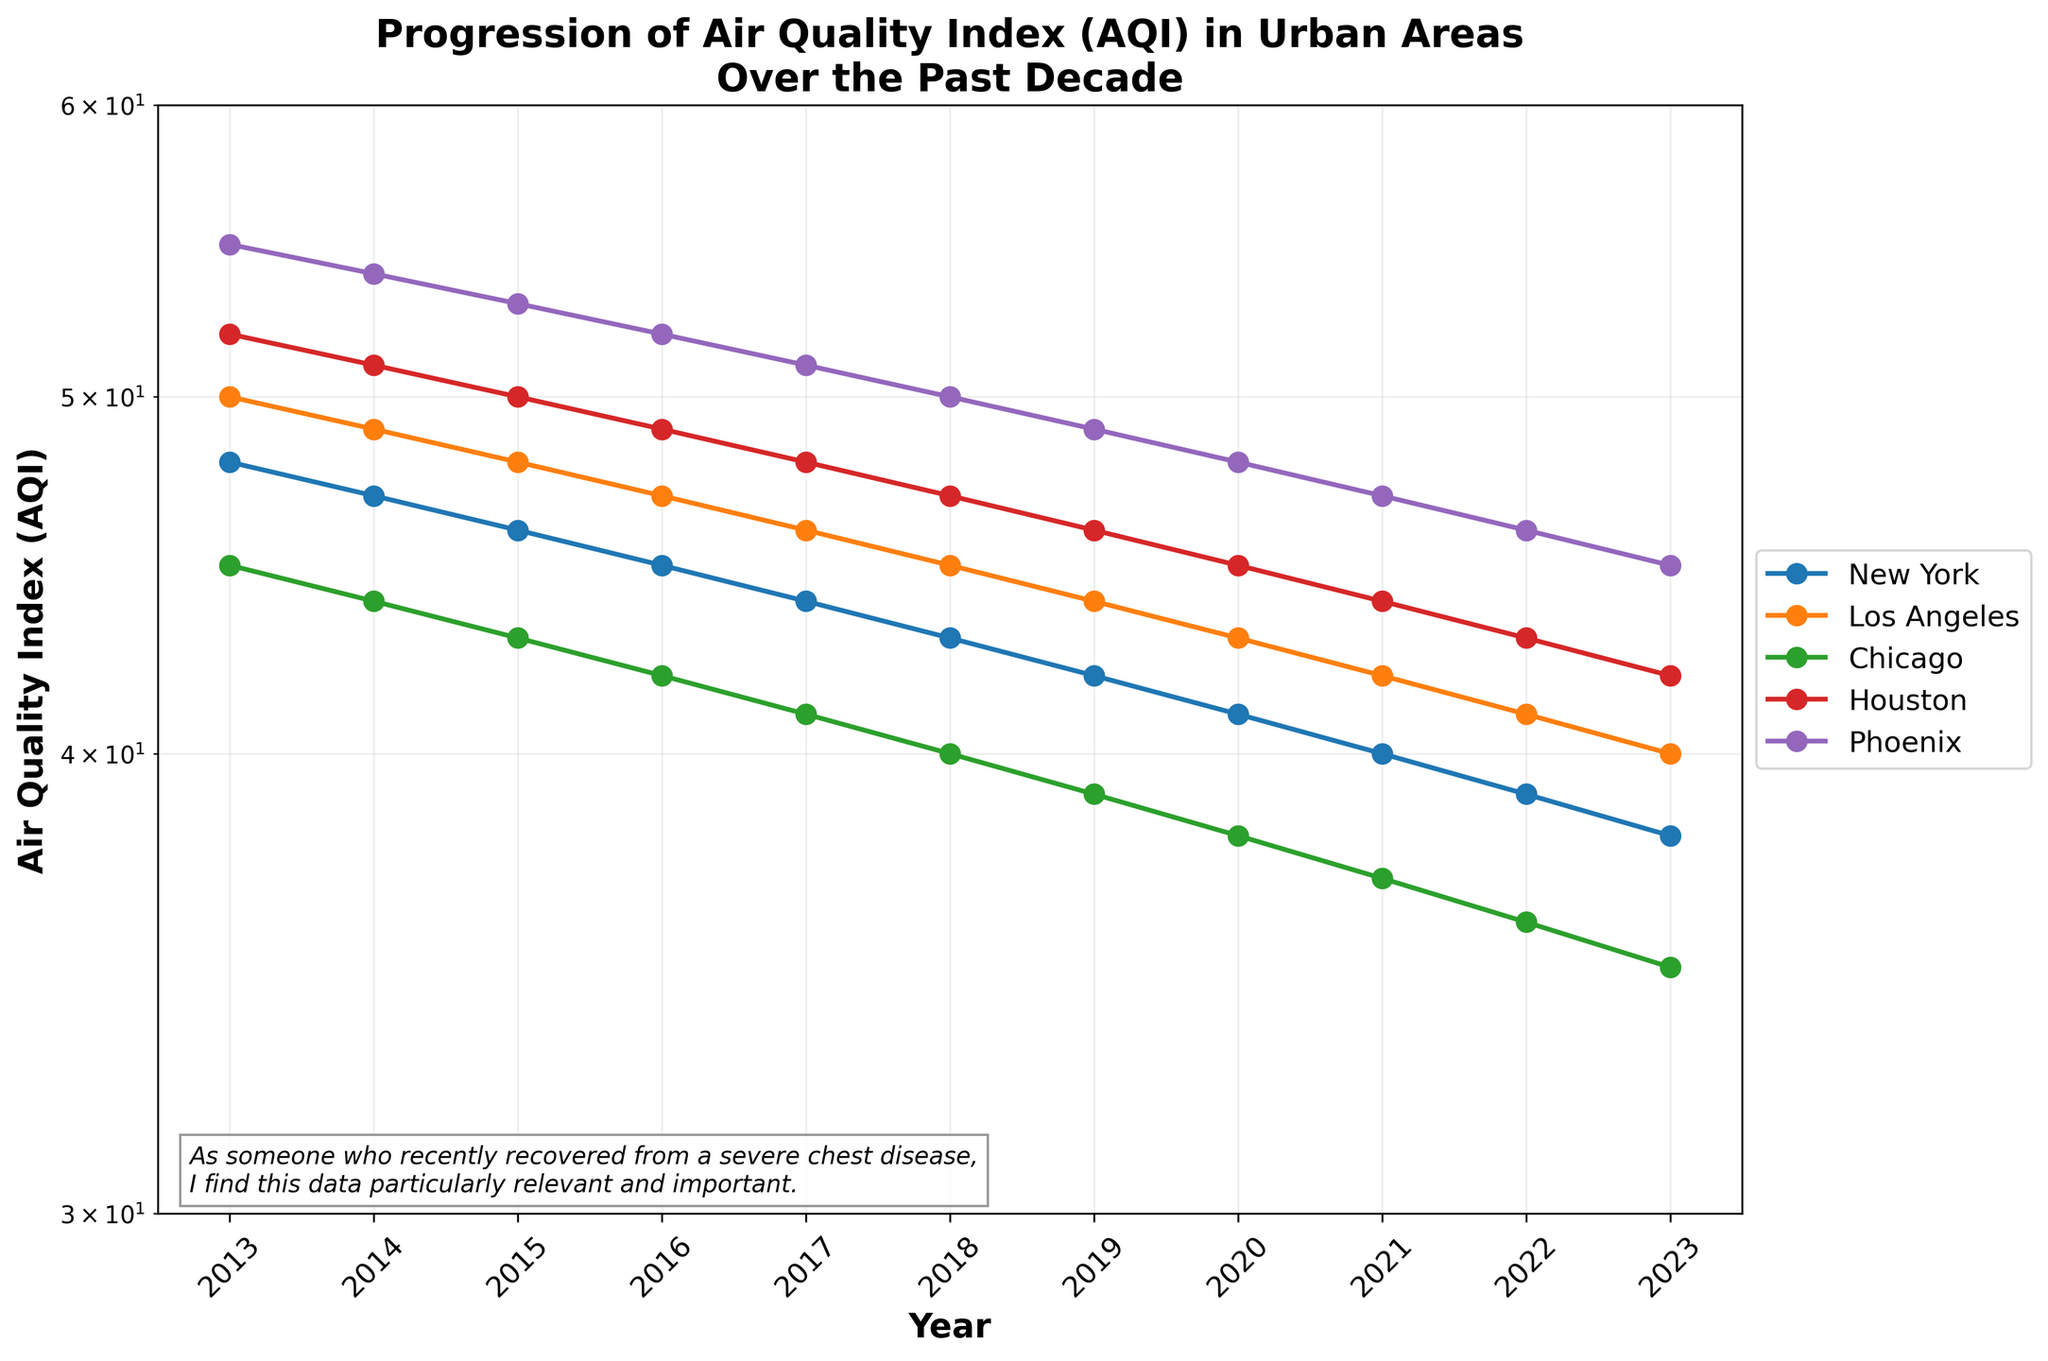What is the title of the plot? The title of the plot is always clearly displayed at the top of the figure. In this case, we can see it reads "Progression of Air Quality Index (AQI) in Urban Areas Over the Past Decade."
Answer: Progression of Air Quality Index (AQI) in Urban Areas Over the Past Decade Which city had the highest AQI in 2013? To find the city with the highest AQI in 2013, we check the line corresponding to each city at the 2013 mark on the x-axis. The plot shows Houston with an AQI of 52, which is the highest value among the cities.
Answer: Houston How does the AQI of Phoenix change from 2013 to 2023? We follow the line representing Phoenix from 2013 to 2023. The AQI starts at 55 in 2013 and reduces gradually each year until it reaches 45 in 2023.
Answer: Decreases from 55 to 45 In which year do all cities have AQI values below 50? We need to examine each city's line in the plot and check when all values fall below 50. We find that from 2019 onwards, all cities have AQI values below 50.
Answer: 2019 Which city had the lowest AQI in 2023 and what is it? We check the end of each city's line for the year 2023. Chicago has the lowest AQI in 2023 at 35.
Answer: Chicago, 35 What is the average AQI of New York from 2013 to 2023? To find the average AQI of New York, we add up all the AQI values for New York over the years and divide by the number of years (11 years). Sum of AQI values: 48+47+46+45+44+43+42+41+40+39+38 = 425. Average is 425/11.
Answer: 38.64 Compare the AQI trend for New York and Los Angeles over the decade. Both cities show a downward trend in AQI over the years. New York starts at 48 in 2013 and drops to 38 in 2023. Los Angeles starts at 50 and drops to 40 in 2023. Both cities' AQI values steadily decrease each year.
Answer: Both decrease steadily, New York (48 to 38), Los Angeles (50 to 40) Which city shows the most significant decrease in AQI over the decade? To determine the city with the most significant decrease, we calculate the difference in AQI from 2013 to 2023 for each city. For Chicago, it's 45-35 = 10. The other cities show less decrease, making Chicago with the largest drop in AQI.
Answer: Chicago What can you infer about the air quality trend across all cities? Observing all city lines, we see a general decreasing trend in AQI over the years, indicating an overall improvement in air quality across the cities from 2013 to 2023.
Answer: Overall improvement How does the log scale affect the appearance of changes in AQI values in the plot? The log scale compresses the differences between larger values and expands differences between smaller values. This makes even gradual changes in AQI appear more noticeable, which highlights the consistent improvements across the decade.
Answer: Compresses large differences, expands small ones 